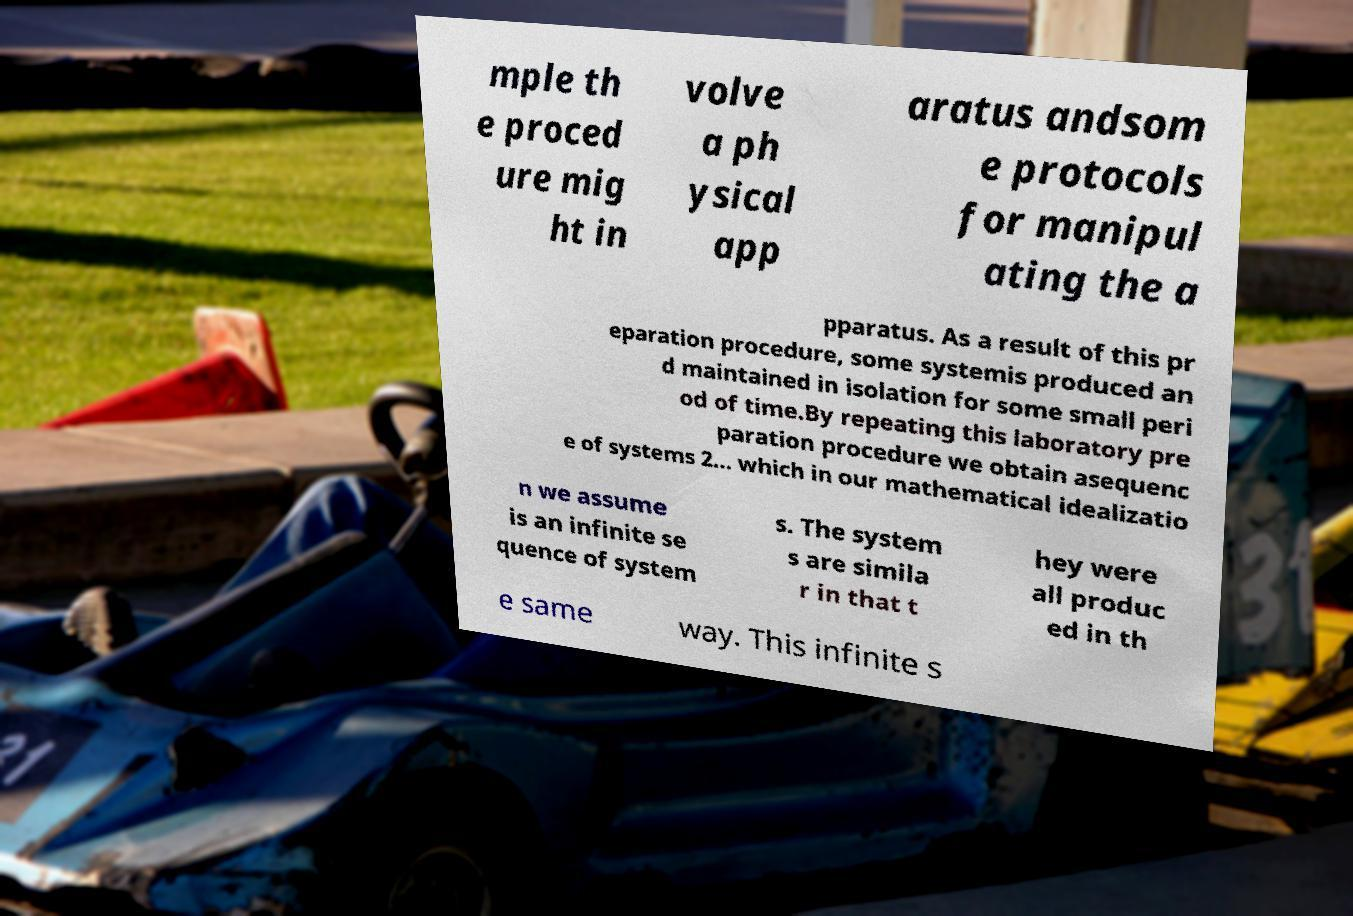Can you read and provide the text displayed in the image?This photo seems to have some interesting text. Can you extract and type it out for me? mple th e proced ure mig ht in volve a ph ysical app aratus andsom e protocols for manipul ating the a pparatus. As a result of this pr eparation procedure, some systemis produced an d maintained in isolation for some small peri od of time.By repeating this laboratory pre paration procedure we obtain asequenc e of systems 2... which in our mathematical idealizatio n we assume is an infinite se quence of system s. The system s are simila r in that t hey were all produc ed in th e same way. This infinite s 